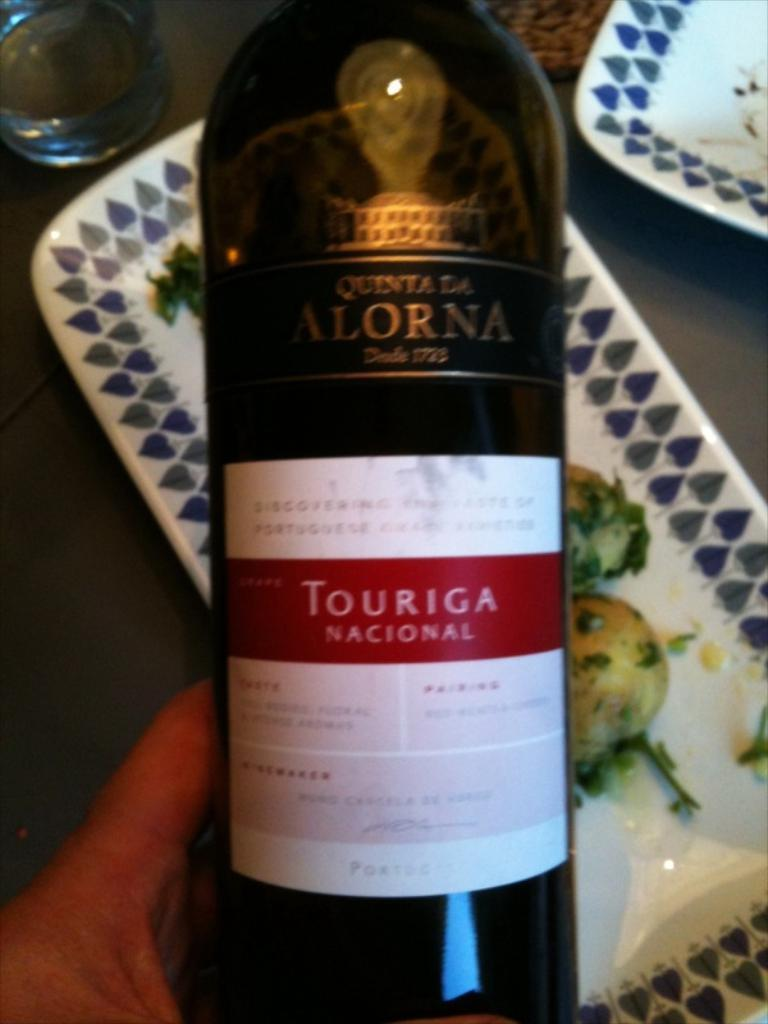<image>
Relay a brief, clear account of the picture shown. A person holds up a bottle of Touriga Nacional. 